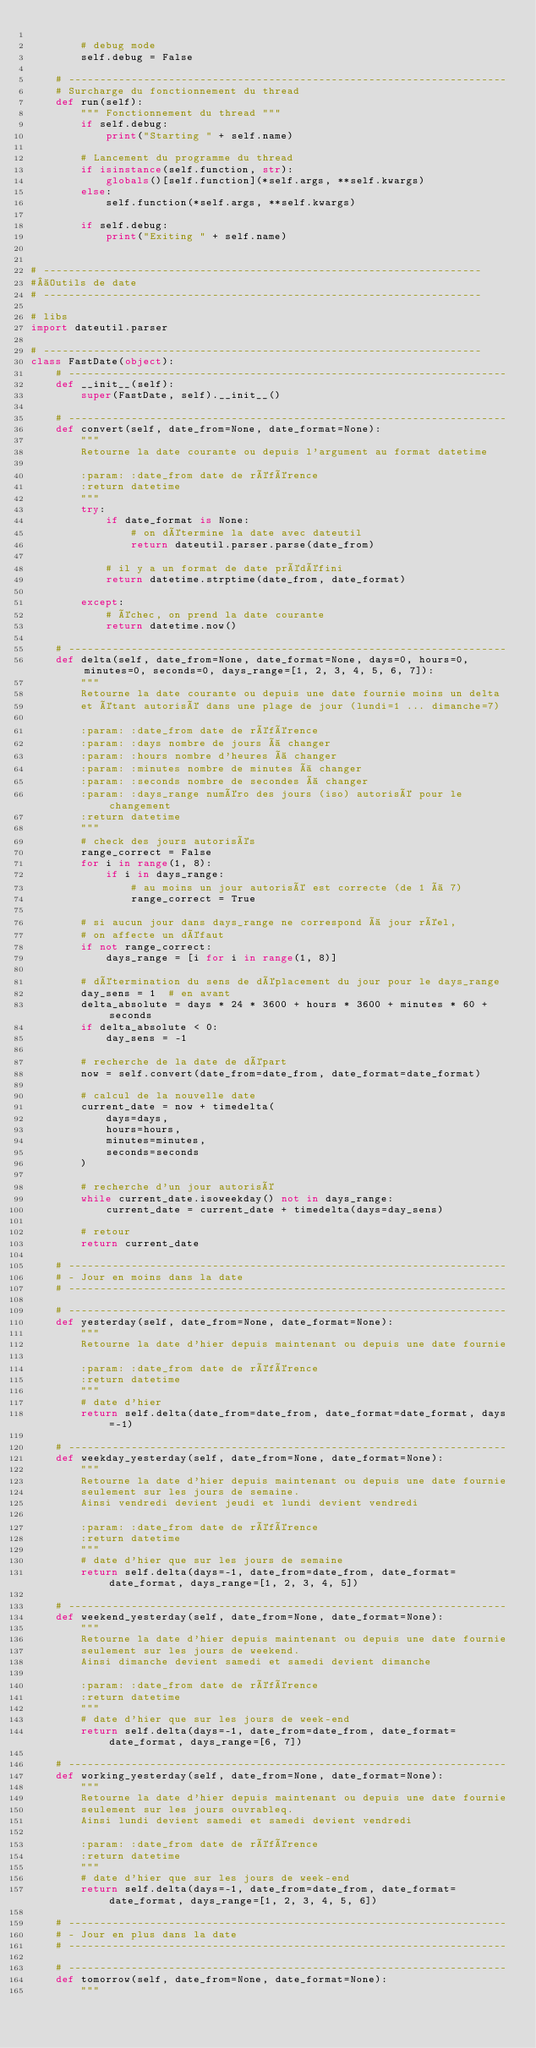<code> <loc_0><loc_0><loc_500><loc_500><_Python_>
		# debug mode
		self.debug = False

	# ----------------------------------------------------------------------
	# Surcharge du fonctionnement du thread
	def run(self):
		""" Fonctionnement du thread """
		if self.debug:
			print("Starting " + self.name)

		# Lancement du programme du thread
		if isinstance(self.function, str):
			globals()[self.function](*self.args, **self.kwargs)
		else:
			self.function(*self.args, **self.kwargs)

		if self.debug:
			print("Exiting " + self.name)


# ----------------------------------------------------------------------
# Outils de date
# ----------------------------------------------------------------------

# libs
import dateutil.parser

# ----------------------------------------------------------------------
class FastDate(object):
	# ----------------------------------------------------------------------
	def __init__(self):
		super(FastDate, self).__init__()

	# ----------------------------------------------------------------------
	def convert(self, date_from=None, date_format=None):
		"""
		Retourne la date courante ou depuis l'argument au format datetime

		:param: :date_from date de référence
		:return datetime
		"""
		try:
			if date_format is None:
				# on détermine la date avec dateutil
				return dateutil.parser.parse(date_from)

			# il y a un format de date prédéfini
			return datetime.strptime(date_from, date_format)

		except:
			# échec, on prend la date courante
			return datetime.now()

	# ----------------------------------------------------------------------
	def delta(self, date_from=None, date_format=None, days=0, hours=0, minutes=0, seconds=0, days_range=[1, 2, 3, 4, 5, 6, 7]):
		"""
		Retourne la date courante ou depuis une date fournie moins un delta
		et étant autorisé dans une plage de jour (lundi=1 ... dimanche=7)

		:param: :date_from date de référence
		:param: :days nombre de jours à changer
		:param: :hours nombre d'heures à changer
		:param: :minutes nombre de minutes à changer
		:param: :seconds nombre de secondes à changer
		:param: :days_range numéro des jours (iso) autorisé pour le changement
		:return datetime
		"""
		# check des jours autorisés
		range_correct = False
		for i in range(1, 8):
			if i in days_range:
				# au moins un jour autorisé est correcte (de 1 à 7)
				range_correct = True

		# si aucun jour dans days_range ne correspond à jour réel,
		# on affecte un défaut
		if not range_correct:
			days_range = [i for i in range(1, 8)]

		# détermination du sens de déplacement du jour pour le days_range
		day_sens = 1  # en avant
		delta_absolute = days * 24 * 3600 + hours * 3600 + minutes * 60 + seconds
		if delta_absolute < 0:
			day_sens = -1

		# recherche de la date de départ
		now = self.convert(date_from=date_from, date_format=date_format)

		# calcul de la nouvelle date
		current_date = now + timedelta(
			days=days,
			hours=hours,
			minutes=minutes,
			seconds=seconds
		)

		# recherche d'un jour autorisé
		while current_date.isoweekday() not in days_range:
			current_date = current_date + timedelta(days=day_sens)

		# retour
		return current_date

	# ----------------------------------------------------------------------
	# - Jour en moins dans la date
	# ----------------------------------------------------------------------

	# ----------------------------------------------------------------------
	def yesterday(self, date_from=None, date_format=None):
		"""
		Retourne la date d'hier depuis maintenant ou depuis une date fournie

		:param: :date_from date de référence
		:return datetime
		"""
		# date d'hier
		return self.delta(date_from=date_from, date_format=date_format, days=-1)

	# ----------------------------------------------------------------------
	def weekday_yesterday(self, date_from=None, date_format=None):
		"""
		Retourne la date d'hier depuis maintenant ou depuis une date fournie
		seulement sur les jours de semaine.
		Ainsi vendredi devient jeudi et lundi devient vendredi

		:param: :date_from date de référence
		:return datetime
		"""
		# date d'hier que sur les jours de semaine
		return self.delta(days=-1, date_from=date_from, date_format=date_format, days_range=[1, 2, 3, 4, 5])

	# ----------------------------------------------------------------------
	def weekend_yesterday(self, date_from=None, date_format=None):
		"""
		Retourne la date d'hier depuis maintenant ou depuis une date fournie
		seulement sur les jours de weekend.
		Ainsi dimanche devient samedi et samedi devient dimanche

		:param: :date_from date de référence
		:return datetime
		"""
		# date d'hier que sur les jours de week-end
		return self.delta(days=-1, date_from=date_from, date_format=date_format, days_range=[6, 7])

	# ----------------------------------------------------------------------
	def working_yesterday(self, date_from=None, date_format=None):
		"""
		Retourne la date d'hier depuis maintenant ou depuis une date fournie
		seulement sur les jours ouvrableq.
		Ainsi lundi devient samedi et samedi devient vendredi

		:param: :date_from date de référence
		:return datetime
		"""
		# date d'hier que sur les jours de week-end
		return self.delta(days=-1, date_from=date_from, date_format=date_format, days_range=[1, 2, 3, 4, 5, 6])

	# ----------------------------------------------------------------------
	# - Jour en plus dans la date
	# ----------------------------------------------------------------------

	# ----------------------------------------------------------------------
	def tomorrow(self, date_from=None, date_format=None):
		"""</code> 